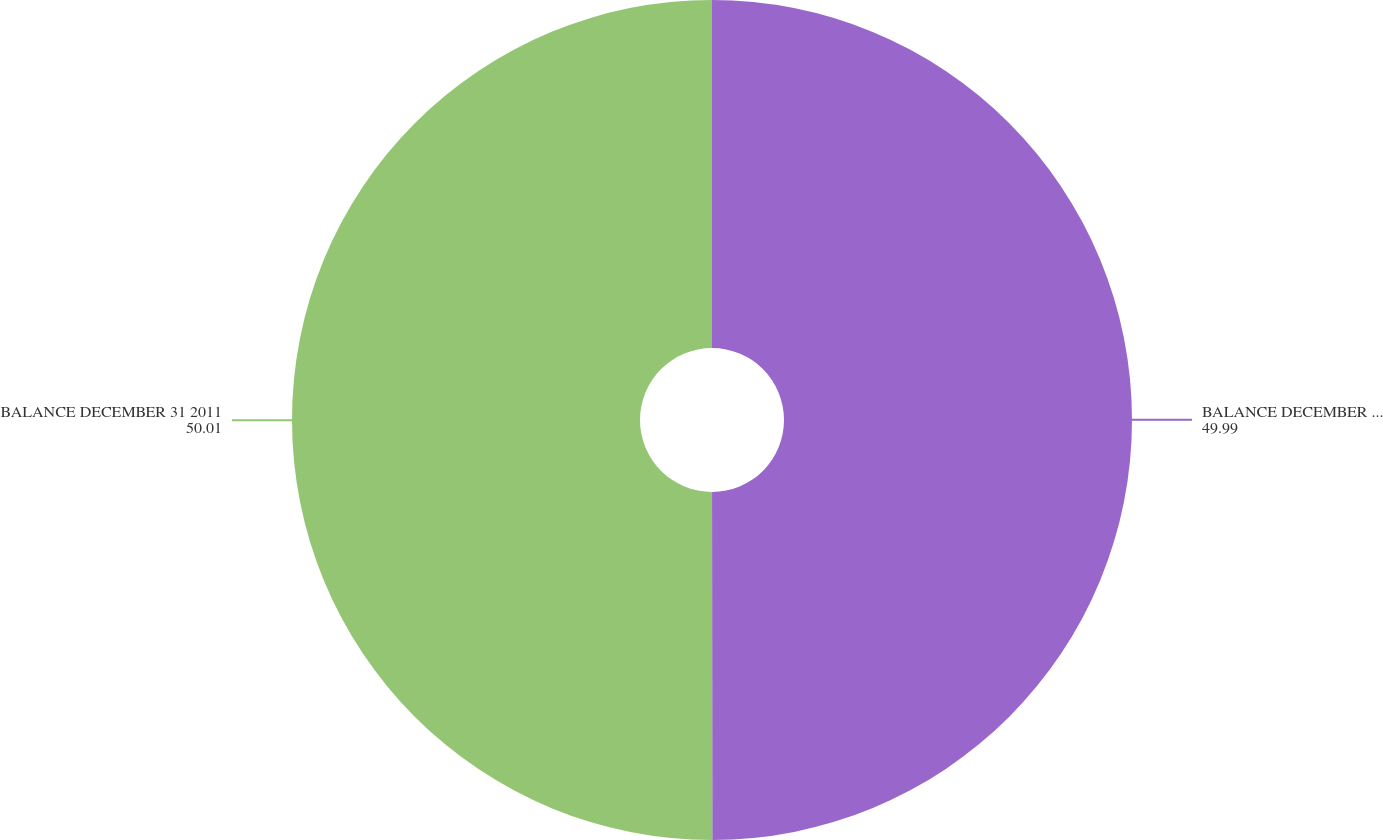<chart> <loc_0><loc_0><loc_500><loc_500><pie_chart><fcel>BALANCE DECEMBER 31 2010<fcel>BALANCE DECEMBER 31 2011<nl><fcel>49.99%<fcel>50.01%<nl></chart> 